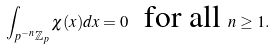<formula> <loc_0><loc_0><loc_500><loc_500>\int _ { p ^ { - n } \mathbb { Z } _ { p } } \chi ( x ) d x = 0 \ \text { for all } n \geq 1 .</formula> 